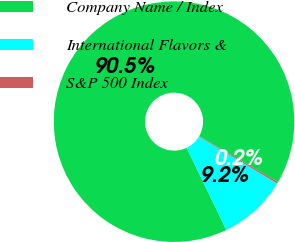Convert chart to OTSL. <chart><loc_0><loc_0><loc_500><loc_500><pie_chart><fcel>Company Name / Index<fcel>International Flavors &<fcel>S&P 500 Index<nl><fcel>90.53%<fcel>9.25%<fcel>0.22%<nl></chart> 